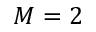<formula> <loc_0><loc_0><loc_500><loc_500>M = 2</formula> 